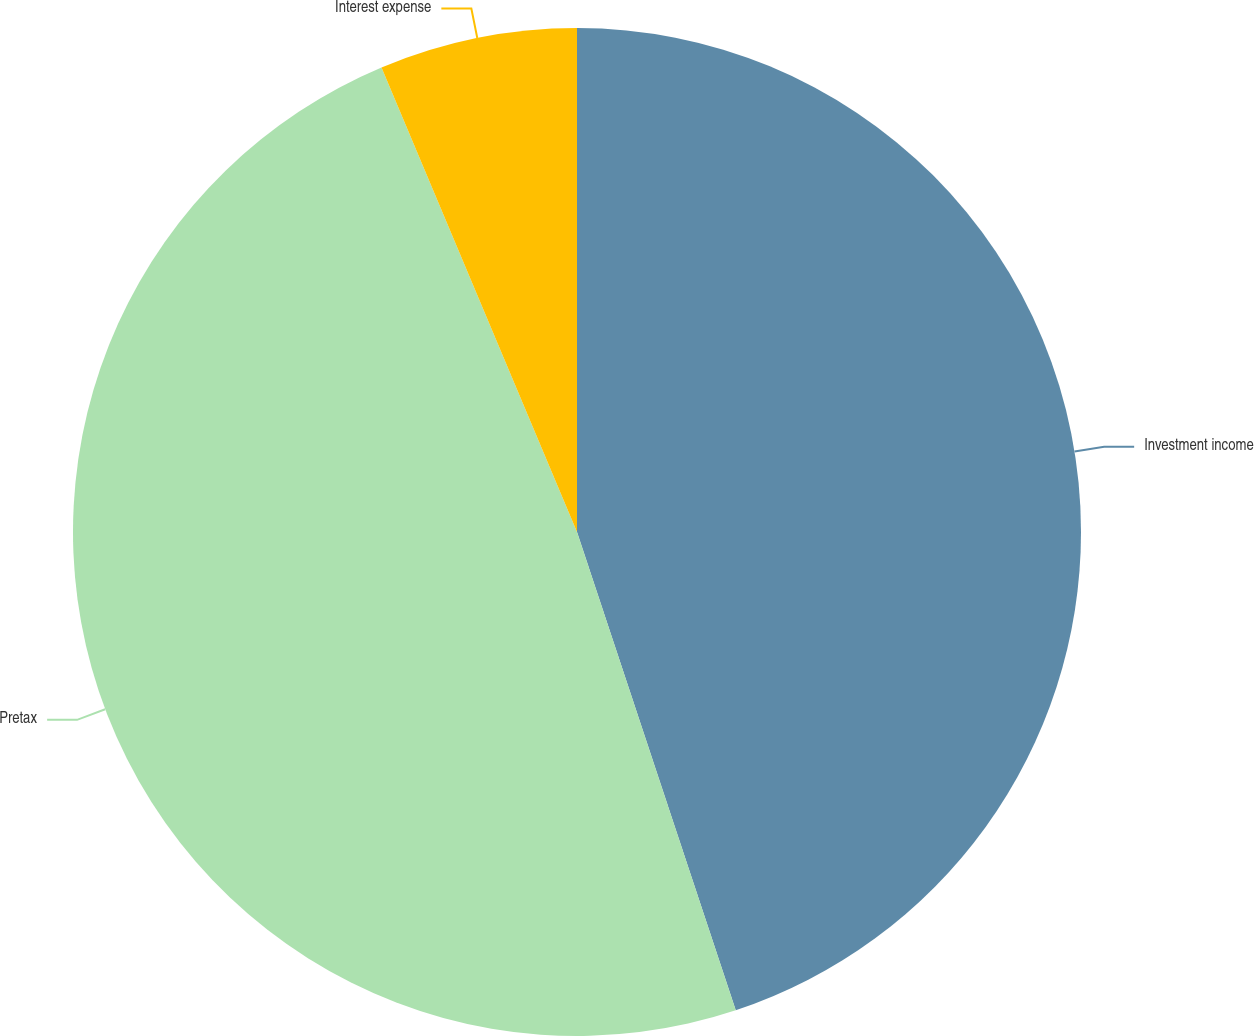Convert chart to OTSL. <chart><loc_0><loc_0><loc_500><loc_500><pie_chart><fcel>Investment income<fcel>Pretax<fcel>Interest expense<nl><fcel>44.9%<fcel>48.76%<fcel>6.34%<nl></chart> 